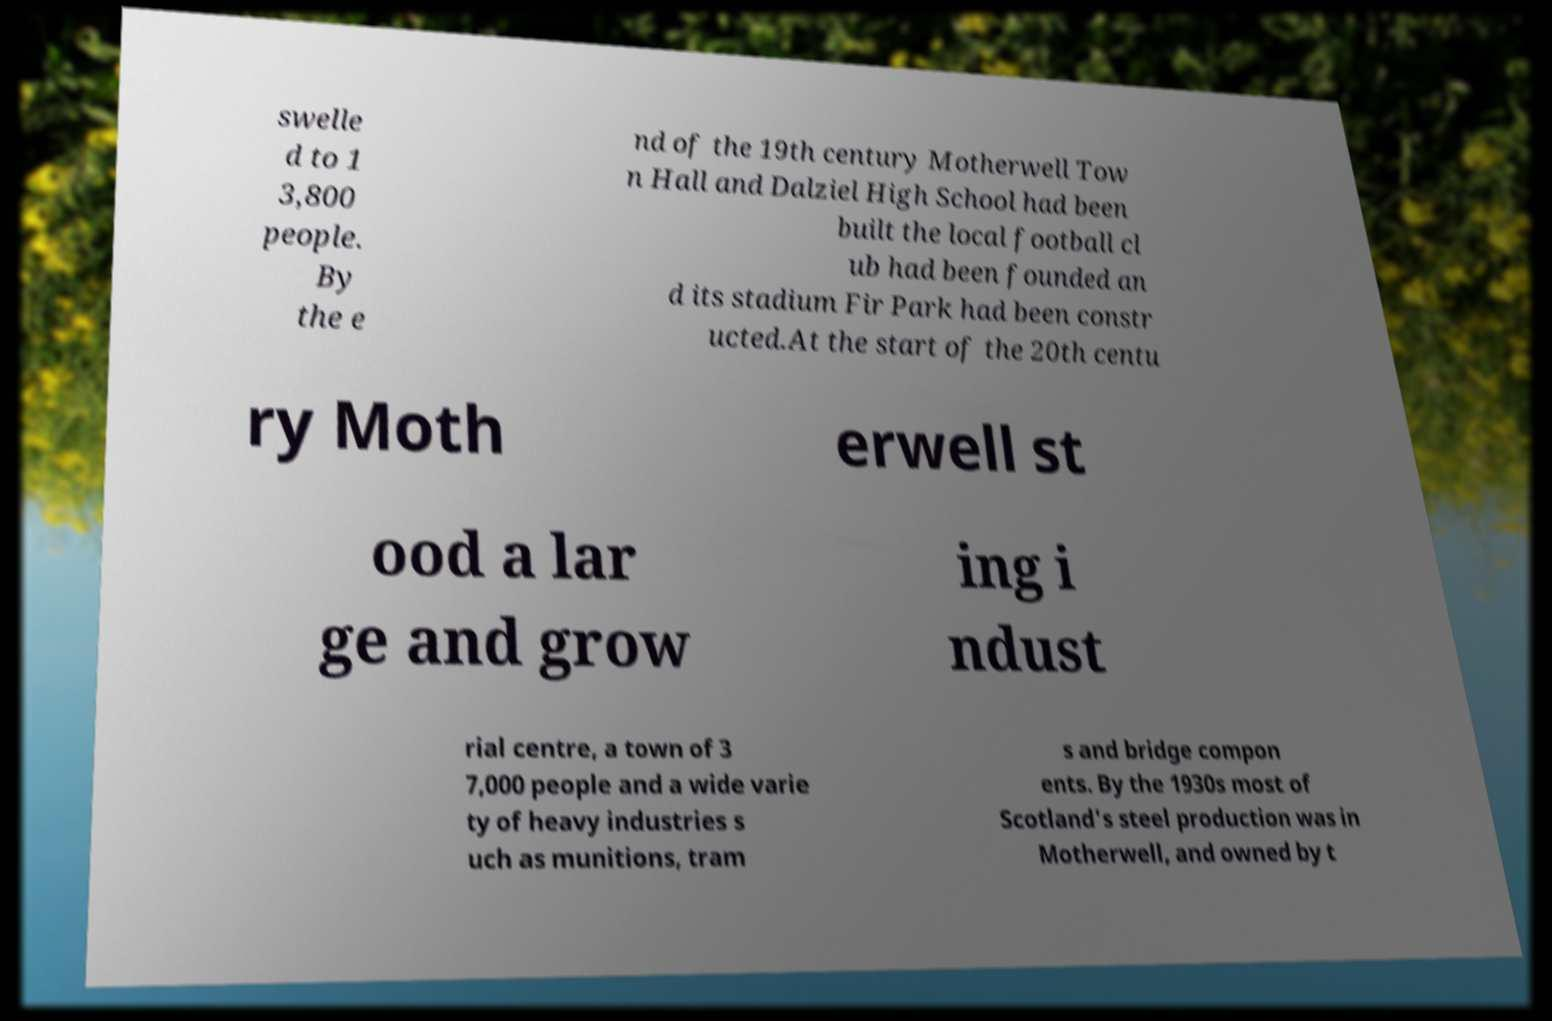I need the written content from this picture converted into text. Can you do that? swelle d to 1 3,800 people. By the e nd of the 19th century Motherwell Tow n Hall and Dalziel High School had been built the local football cl ub had been founded an d its stadium Fir Park had been constr ucted.At the start of the 20th centu ry Moth erwell st ood a lar ge and grow ing i ndust rial centre, a town of 3 7,000 people and a wide varie ty of heavy industries s uch as munitions, tram s and bridge compon ents. By the 1930s most of Scotland's steel production was in Motherwell, and owned by t 